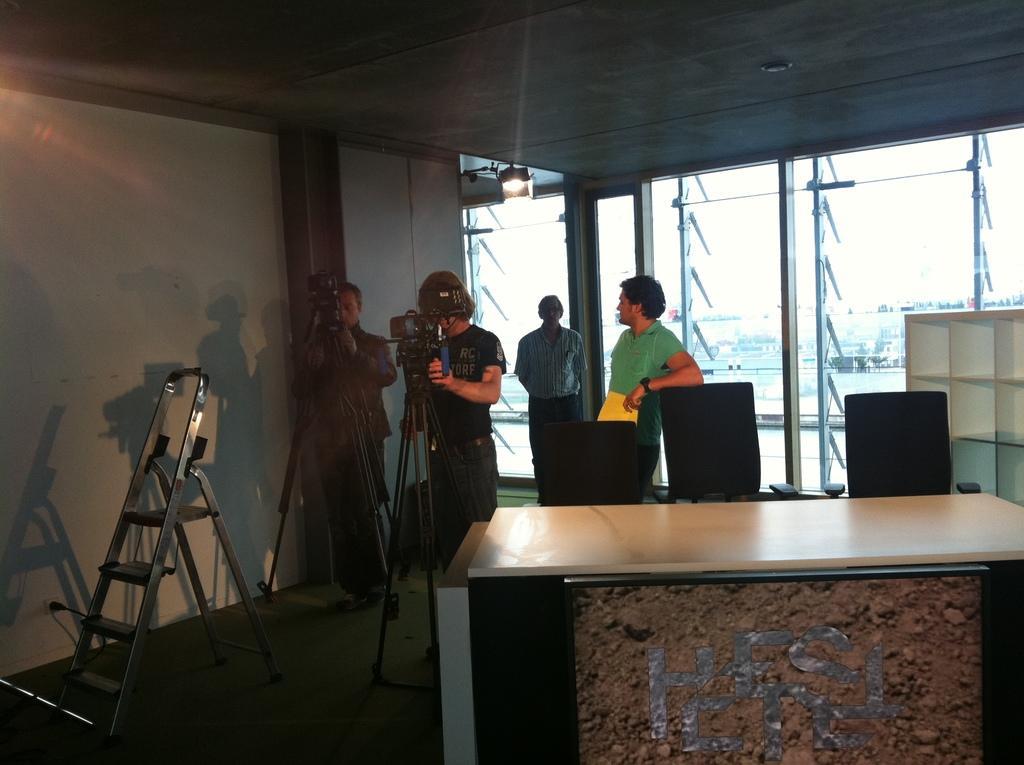Could you give a brief overview of what you see in this image? In the middle there are four persons standing in front of the chair and in front of camera stand. At the bottle table is there. The walls are white in color and a roof top is there. In the middle windows are visible through which sky and buildings are visible and a ladder is there. This image is taken inside a room. 